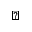<formula> <loc_0><loc_0><loc_500><loc_500>\triangleleft</formula> 